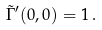<formula> <loc_0><loc_0><loc_500><loc_500>\tilde { \Gamma } ^ { \prime } ( 0 , 0 ) = 1 \, .</formula> 